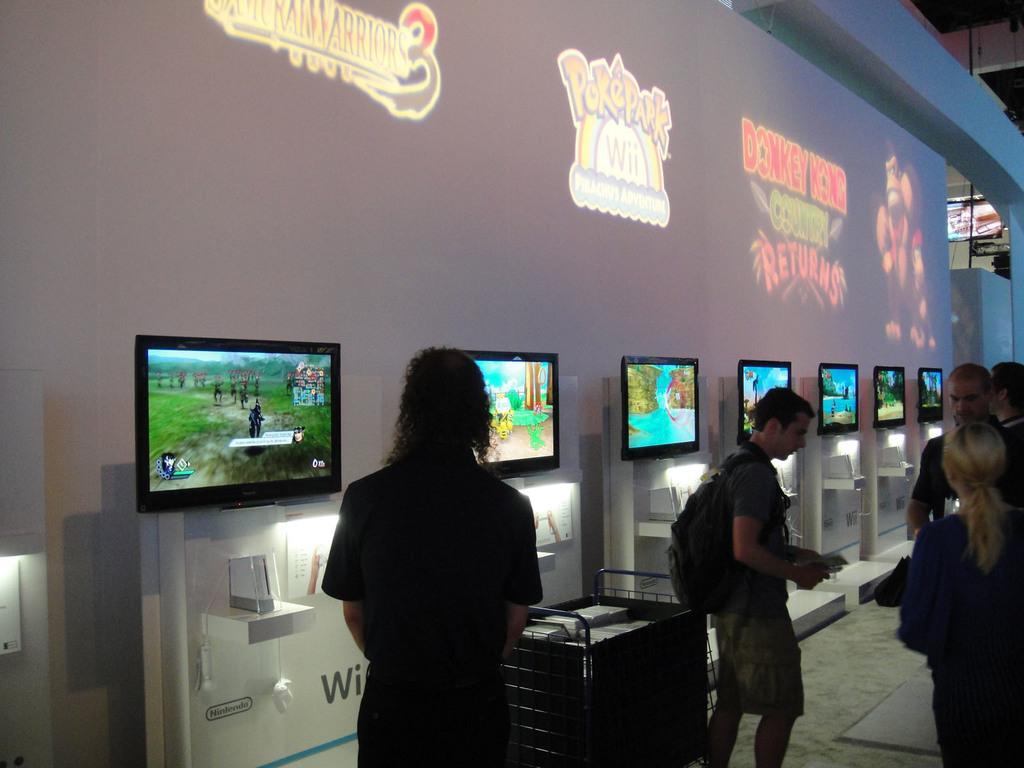In one or two sentences, can you explain what this image depicts? There are people in the foreground area of the image, there are televisions, it seems like posters and other objects in the background. 